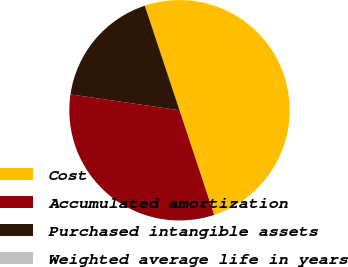<chart> <loc_0><loc_0><loc_500><loc_500><pie_chart><fcel>Cost<fcel>Accumulated amortization<fcel>Purchased intangible assets<fcel>Weighted average life in years<nl><fcel>50.0%<fcel>32.39%<fcel>17.6%<fcel>0.01%<nl></chart> 